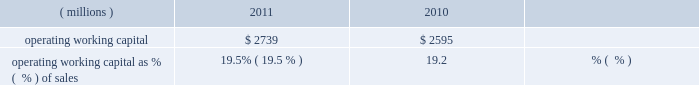Liquidity and capital resources during the past three years , we had sufficient financial resources to meet our operating requirements , to fund our capital spending , share repurchases and pension plans and to pay increasing dividends to our shareholders .
Cash from operating activities was $ 1436 million , $ 1310 million , and $ 1345 million in 2011 , 2010 , and 2009 , respectively .
Higher earnings increased cash from operations in 2011 compared to 2010 , but the increase was reduced by cash used to fund an increase in working capital of $ 212 million driven by our sales growth in 2011 .
Cash provided by working capital was greater in 2009 than 2010 and that decline was more than offset by the cash from higher 2010 earnings .
Operating working capital is a subset of total working capital and represents ( 1 ) trade receivables-net of the allowance for doubtful accounts , plus ( 2 ) inventories on a first-in , first-out ( 201cfifo 201d ) basis , less ( 3 ) trade creditors 2019 liabilities .
See note 3 , 201cworking capital detail 201d under item 8 of this form 10-k for further information related to the components of the company 2019s operating working capital .
We believe operating working capital represents the key components of working capital under the operating control of our businesses .
Operating working capital at december 31 , 2011 and 2010 was $ 2.7 billion and $ 2.6 billion , respectively .
A key metric we use to measure our working capital management is operating working capital as a percentage of sales ( fourth quarter sales annualized ) .
( millions ) 2011 2010 operating working capital $ 2739 $ 2595 operating working capital as % (  % ) of sales 19.5% ( 19.5 % ) 19.2% ( 19.2 % ) the change in operating working capital elements , excluding the impact of currency and acquisitions , was an increase of $ 195 million during the year ended december 31 , 2011 .
This increase was the net result of an increase in receivables from customers associated with the 2011 increase in sales and an increase in fifo inventory slightly offset by an increase in trade creditors 2019 liabilities .
Trade receivables from customers , net , as a percentage of fourth quarter sales , annualized , for 2011 was 17.9 percent , down slightly from 18.1 percent for 2010 .
Days sales outstanding was 66 days in 2011 , level with 2010 .
Inventories on a fifo basis as a percentage of fourth quarter sales , annualized , for 2011 was 13.1 percent level with 2010 .
Inventory turnover was 5.0 times in 2011 and 4.6 times in 2010 .
Total capital spending , including acquisitions , was $ 446 million , $ 341 million and $ 265 million in 2011 , 2010 , and 2009 , respectively .
Spending related to modernization and productivity improvements , expansion of existing businesses and environmental control projects was $ 390 million , $ 307 million and $ 239 million in 2011 , 2010 , and 2009 , respectively , and is expected to be in the range of $ 450-$ 550 million during 2012 .
Capital spending , excluding acquisitions , as a percentage of sales was 2.6% ( 2.6 % ) , 2.3% ( 2.3 % ) and 2.0% ( 2.0 % ) in 2011 , 2010 and 2009 , respectively .
Capital spending related to business acquisitions amounted to $ 56 million , $ 34 million , and $ 26 million in 2011 , 2010 and 2009 , respectively .
We continue to evaluate acquisition opportunities and expect to use cash in 2012 to fund small to mid-sized acquisitions , as part of a balanced deployment of our cash to support growth in earnings .
In january 2012 , the company closed the previously announced acquisitions of colpisa , a colombian producer of automotive oem and refinish coatings , and dyrup , a european architectural coatings company .
The cost of these acquisitions , including assumed debt , was $ 193 million .
Dividends paid to shareholders totaled $ 355 million , $ 360 million and $ 353 million in 2011 , 2010 and 2009 , respectively .
Ppg has paid uninterrupted annual dividends since 1899 , and 2011 marked the 40th consecutive year of increased annual dividend payments to shareholders .
We did not have a mandatory contribution to our u.s .
Defined benefit pension plans in 2011 ; however , we made voluntary contributions to these plans in 2011 totaling $ 50 million .
In 2010 and 2009 , we made voluntary contributions to our u.s .
Defined benefit pension plans of $ 250 and $ 360 million ( of which $ 100 million was made in ppg stock ) , respectively .
We expect to make voluntary contributions to our u.s .
Defined benefit pension plans in 2012 of up to $ 60 million .
Contributions were made to our non-u.s .
Defined benefit pension plans of $ 71 million , $ 87 million and $ 90 million ( of which approximately $ 20 million was made in ppg stock ) for 2011 , 2010 and 2009 , respectively , some of which were required by local funding requirements .
We expect to make mandatory contributions to our non-u.s .
Plans in 2012 of approximately $ 90 million .
The company 2019s share repurchase activity in 2011 , 2010 and 2009 was 10.2 million shares at a cost of $ 858 million , 8.1 million shares at a cost of $ 586 million and 1.5 million shares at a cost of $ 59 million , respectively .
We expect to make share repurchases in 2012 as part of our cash deployment focused on earnings growth .
The amount of spending will depend on the level of acquisition spending and other uses of cash , but we currently expect to spend in the range of $ 250 million to $ 500 million on share repurchases in 2012 .
We can repurchase about 9 million shares under the current authorization from the board of directors .
26 2011 ppg annual report and form 10-k .
Liquidity and capital resources during the past three years , we had sufficient financial resources to meet our operating requirements , to fund our capital spending , share repurchases and pension plans and to pay increasing dividends to our shareholders .
Cash from operating activities was $ 1436 million , $ 1310 million , and $ 1345 million in 2011 , 2010 , and 2009 , respectively .
Higher earnings increased cash from operations in 2011 compared to 2010 , but the increase was reduced by cash used to fund an increase in working capital of $ 212 million driven by our sales growth in 2011 .
Cash provided by working capital was greater in 2009 than 2010 and that decline was more than offset by the cash from higher 2010 earnings .
Operating working capital is a subset of total working capital and represents ( 1 ) trade receivables-net of the allowance for doubtful accounts , plus ( 2 ) inventories on a first-in , first-out ( 201cfifo 201d ) basis , less ( 3 ) trade creditors 2019 liabilities .
See note 3 , 201cworking capital detail 201d under item 8 of this form 10-k for further information related to the components of the company 2019s operating working capital .
We believe operating working capital represents the key components of working capital under the operating control of our businesses .
Operating working capital at december 31 , 2011 and 2010 was $ 2.7 billion and $ 2.6 billion , respectively .
A key metric we use to measure our working capital management is operating working capital as a percentage of sales ( fourth quarter sales annualized ) .
( millions ) 2011 2010 operating working capital $ 2739 $ 2595 operating working capital as % (  % ) of sales 19.5% ( 19.5 % ) 19.2% ( 19.2 % ) the change in operating working capital elements , excluding the impact of currency and acquisitions , was an increase of $ 195 million during the year ended december 31 , 2011 .
This increase was the net result of an increase in receivables from customers associated with the 2011 increase in sales and an increase in fifo inventory slightly offset by an increase in trade creditors 2019 liabilities .
Trade receivables from customers , net , as a percentage of fourth quarter sales , annualized , for 2011 was 17.9 percent , down slightly from 18.1 percent for 2010 .
Days sales outstanding was 66 days in 2011 , level with 2010 .
Inventories on a fifo basis as a percentage of fourth quarter sales , annualized , for 2011 was 13.1 percent level with 2010 .
Inventory turnover was 5.0 times in 2011 and 4.6 times in 2010 .
Total capital spending , including acquisitions , was $ 446 million , $ 341 million and $ 265 million in 2011 , 2010 , and 2009 , respectively .
Spending related to modernization and productivity improvements , expansion of existing businesses and environmental control projects was $ 390 million , $ 307 million and $ 239 million in 2011 , 2010 , and 2009 , respectively , and is expected to be in the range of $ 450-$ 550 million during 2012 .
Capital spending , excluding acquisitions , as a percentage of sales was 2.6% ( 2.6 % ) , 2.3% ( 2.3 % ) and 2.0% ( 2.0 % ) in 2011 , 2010 and 2009 , respectively .
Capital spending related to business acquisitions amounted to $ 56 million , $ 34 million , and $ 26 million in 2011 , 2010 and 2009 , respectively .
We continue to evaluate acquisition opportunities and expect to use cash in 2012 to fund small to mid-sized acquisitions , as part of a balanced deployment of our cash to support growth in earnings .
In january 2012 , the company closed the previously announced acquisitions of colpisa , a colombian producer of automotive oem and refinish coatings , and dyrup , a european architectural coatings company .
The cost of these acquisitions , including assumed debt , was $ 193 million .
Dividends paid to shareholders totaled $ 355 million , $ 360 million and $ 353 million in 2011 , 2010 and 2009 , respectively .
Ppg has paid uninterrupted annual dividends since 1899 , and 2011 marked the 40th consecutive year of increased annual dividend payments to shareholders .
We did not have a mandatory contribution to our u.s .
Defined benefit pension plans in 2011 ; however , we made voluntary contributions to these plans in 2011 totaling $ 50 million .
In 2010 and 2009 , we made voluntary contributions to our u.s .
Defined benefit pension plans of $ 250 and $ 360 million ( of which $ 100 million was made in ppg stock ) , respectively .
We expect to make voluntary contributions to our u.s .
Defined benefit pension plans in 2012 of up to $ 60 million .
Contributions were made to our non-u.s .
Defined benefit pension plans of $ 71 million , $ 87 million and $ 90 million ( of which approximately $ 20 million was made in ppg stock ) for 2011 , 2010 and 2009 , respectively , some of which were required by local funding requirements .
We expect to make mandatory contributions to our non-u.s .
Plans in 2012 of approximately $ 90 million .
The company 2019s share repurchase activity in 2011 , 2010 and 2009 was 10.2 million shares at a cost of $ 858 million , 8.1 million shares at a cost of $ 586 million and 1.5 million shares at a cost of $ 59 million , respectively .
We expect to make share repurchases in 2012 as part of our cash deployment focused on earnings growth .
The amount of spending will depend on the level of acquisition spending and other uses of cash , but we currently expect to spend in the range of $ 250 million to $ 500 million on share repurchases in 2012 .
We can repurchase about 9 million shares under the current authorization from the board of directors .
26 2011 ppg annual report and form 10-k .
If trade receivables from customers trends at the same rate as 2011 , what will the 2012 allowance be as a percentage of fourth quarter sales? 
Computations: (17.9 - (17.9 - 18.1))
Answer: 18.1. Liquidity and capital resources during the past three years , we had sufficient financial resources to meet our operating requirements , to fund our capital spending , share repurchases and pension plans and to pay increasing dividends to our shareholders .
Cash from operating activities was $ 1436 million , $ 1310 million , and $ 1345 million in 2011 , 2010 , and 2009 , respectively .
Higher earnings increased cash from operations in 2011 compared to 2010 , but the increase was reduced by cash used to fund an increase in working capital of $ 212 million driven by our sales growth in 2011 .
Cash provided by working capital was greater in 2009 than 2010 and that decline was more than offset by the cash from higher 2010 earnings .
Operating working capital is a subset of total working capital and represents ( 1 ) trade receivables-net of the allowance for doubtful accounts , plus ( 2 ) inventories on a first-in , first-out ( 201cfifo 201d ) basis , less ( 3 ) trade creditors 2019 liabilities .
See note 3 , 201cworking capital detail 201d under item 8 of this form 10-k for further information related to the components of the company 2019s operating working capital .
We believe operating working capital represents the key components of working capital under the operating control of our businesses .
Operating working capital at december 31 , 2011 and 2010 was $ 2.7 billion and $ 2.6 billion , respectively .
A key metric we use to measure our working capital management is operating working capital as a percentage of sales ( fourth quarter sales annualized ) .
( millions ) 2011 2010 operating working capital $ 2739 $ 2595 operating working capital as % (  % ) of sales 19.5% ( 19.5 % ) 19.2% ( 19.2 % ) the change in operating working capital elements , excluding the impact of currency and acquisitions , was an increase of $ 195 million during the year ended december 31 , 2011 .
This increase was the net result of an increase in receivables from customers associated with the 2011 increase in sales and an increase in fifo inventory slightly offset by an increase in trade creditors 2019 liabilities .
Trade receivables from customers , net , as a percentage of fourth quarter sales , annualized , for 2011 was 17.9 percent , down slightly from 18.1 percent for 2010 .
Days sales outstanding was 66 days in 2011 , level with 2010 .
Inventories on a fifo basis as a percentage of fourth quarter sales , annualized , for 2011 was 13.1 percent level with 2010 .
Inventory turnover was 5.0 times in 2011 and 4.6 times in 2010 .
Total capital spending , including acquisitions , was $ 446 million , $ 341 million and $ 265 million in 2011 , 2010 , and 2009 , respectively .
Spending related to modernization and productivity improvements , expansion of existing businesses and environmental control projects was $ 390 million , $ 307 million and $ 239 million in 2011 , 2010 , and 2009 , respectively , and is expected to be in the range of $ 450-$ 550 million during 2012 .
Capital spending , excluding acquisitions , as a percentage of sales was 2.6% ( 2.6 % ) , 2.3% ( 2.3 % ) and 2.0% ( 2.0 % ) in 2011 , 2010 and 2009 , respectively .
Capital spending related to business acquisitions amounted to $ 56 million , $ 34 million , and $ 26 million in 2011 , 2010 and 2009 , respectively .
We continue to evaluate acquisition opportunities and expect to use cash in 2012 to fund small to mid-sized acquisitions , as part of a balanced deployment of our cash to support growth in earnings .
In january 2012 , the company closed the previously announced acquisitions of colpisa , a colombian producer of automotive oem and refinish coatings , and dyrup , a european architectural coatings company .
The cost of these acquisitions , including assumed debt , was $ 193 million .
Dividends paid to shareholders totaled $ 355 million , $ 360 million and $ 353 million in 2011 , 2010 and 2009 , respectively .
Ppg has paid uninterrupted annual dividends since 1899 , and 2011 marked the 40th consecutive year of increased annual dividend payments to shareholders .
We did not have a mandatory contribution to our u.s .
Defined benefit pension plans in 2011 ; however , we made voluntary contributions to these plans in 2011 totaling $ 50 million .
In 2010 and 2009 , we made voluntary contributions to our u.s .
Defined benefit pension plans of $ 250 and $ 360 million ( of which $ 100 million was made in ppg stock ) , respectively .
We expect to make voluntary contributions to our u.s .
Defined benefit pension plans in 2012 of up to $ 60 million .
Contributions were made to our non-u.s .
Defined benefit pension plans of $ 71 million , $ 87 million and $ 90 million ( of which approximately $ 20 million was made in ppg stock ) for 2011 , 2010 and 2009 , respectively , some of which were required by local funding requirements .
We expect to make mandatory contributions to our non-u.s .
Plans in 2012 of approximately $ 90 million .
The company 2019s share repurchase activity in 2011 , 2010 and 2009 was 10.2 million shares at a cost of $ 858 million , 8.1 million shares at a cost of $ 586 million and 1.5 million shares at a cost of $ 59 million , respectively .
We expect to make share repurchases in 2012 as part of our cash deployment focused on earnings growth .
The amount of spending will depend on the level of acquisition spending and other uses of cash , but we currently expect to spend in the range of $ 250 million to $ 500 million on share repurchases in 2012 .
We can repurchase about 9 million shares under the current authorization from the board of directors .
26 2011 ppg annual report and form 10-k .
Liquidity and capital resources during the past three years , we had sufficient financial resources to meet our operating requirements , to fund our capital spending , share repurchases and pension plans and to pay increasing dividends to our shareholders .
Cash from operating activities was $ 1436 million , $ 1310 million , and $ 1345 million in 2011 , 2010 , and 2009 , respectively .
Higher earnings increased cash from operations in 2011 compared to 2010 , but the increase was reduced by cash used to fund an increase in working capital of $ 212 million driven by our sales growth in 2011 .
Cash provided by working capital was greater in 2009 than 2010 and that decline was more than offset by the cash from higher 2010 earnings .
Operating working capital is a subset of total working capital and represents ( 1 ) trade receivables-net of the allowance for doubtful accounts , plus ( 2 ) inventories on a first-in , first-out ( 201cfifo 201d ) basis , less ( 3 ) trade creditors 2019 liabilities .
See note 3 , 201cworking capital detail 201d under item 8 of this form 10-k for further information related to the components of the company 2019s operating working capital .
We believe operating working capital represents the key components of working capital under the operating control of our businesses .
Operating working capital at december 31 , 2011 and 2010 was $ 2.7 billion and $ 2.6 billion , respectively .
A key metric we use to measure our working capital management is operating working capital as a percentage of sales ( fourth quarter sales annualized ) .
( millions ) 2011 2010 operating working capital $ 2739 $ 2595 operating working capital as % (  % ) of sales 19.5% ( 19.5 % ) 19.2% ( 19.2 % ) the change in operating working capital elements , excluding the impact of currency and acquisitions , was an increase of $ 195 million during the year ended december 31 , 2011 .
This increase was the net result of an increase in receivables from customers associated with the 2011 increase in sales and an increase in fifo inventory slightly offset by an increase in trade creditors 2019 liabilities .
Trade receivables from customers , net , as a percentage of fourth quarter sales , annualized , for 2011 was 17.9 percent , down slightly from 18.1 percent for 2010 .
Days sales outstanding was 66 days in 2011 , level with 2010 .
Inventories on a fifo basis as a percentage of fourth quarter sales , annualized , for 2011 was 13.1 percent level with 2010 .
Inventory turnover was 5.0 times in 2011 and 4.6 times in 2010 .
Total capital spending , including acquisitions , was $ 446 million , $ 341 million and $ 265 million in 2011 , 2010 , and 2009 , respectively .
Spending related to modernization and productivity improvements , expansion of existing businesses and environmental control projects was $ 390 million , $ 307 million and $ 239 million in 2011 , 2010 , and 2009 , respectively , and is expected to be in the range of $ 450-$ 550 million during 2012 .
Capital spending , excluding acquisitions , as a percentage of sales was 2.6% ( 2.6 % ) , 2.3% ( 2.3 % ) and 2.0% ( 2.0 % ) in 2011 , 2010 and 2009 , respectively .
Capital spending related to business acquisitions amounted to $ 56 million , $ 34 million , and $ 26 million in 2011 , 2010 and 2009 , respectively .
We continue to evaluate acquisition opportunities and expect to use cash in 2012 to fund small to mid-sized acquisitions , as part of a balanced deployment of our cash to support growth in earnings .
In january 2012 , the company closed the previously announced acquisitions of colpisa , a colombian producer of automotive oem and refinish coatings , and dyrup , a european architectural coatings company .
The cost of these acquisitions , including assumed debt , was $ 193 million .
Dividends paid to shareholders totaled $ 355 million , $ 360 million and $ 353 million in 2011 , 2010 and 2009 , respectively .
Ppg has paid uninterrupted annual dividends since 1899 , and 2011 marked the 40th consecutive year of increased annual dividend payments to shareholders .
We did not have a mandatory contribution to our u.s .
Defined benefit pension plans in 2011 ; however , we made voluntary contributions to these plans in 2011 totaling $ 50 million .
In 2010 and 2009 , we made voluntary contributions to our u.s .
Defined benefit pension plans of $ 250 and $ 360 million ( of which $ 100 million was made in ppg stock ) , respectively .
We expect to make voluntary contributions to our u.s .
Defined benefit pension plans in 2012 of up to $ 60 million .
Contributions were made to our non-u.s .
Defined benefit pension plans of $ 71 million , $ 87 million and $ 90 million ( of which approximately $ 20 million was made in ppg stock ) for 2011 , 2010 and 2009 , respectively , some of which were required by local funding requirements .
We expect to make mandatory contributions to our non-u.s .
Plans in 2012 of approximately $ 90 million .
The company 2019s share repurchase activity in 2011 , 2010 and 2009 was 10.2 million shares at a cost of $ 858 million , 8.1 million shares at a cost of $ 586 million and 1.5 million shares at a cost of $ 59 million , respectively .
We expect to make share repurchases in 2012 as part of our cash deployment focused on earnings growth .
The amount of spending will depend on the level of acquisition spending and other uses of cash , but we currently expect to spend in the range of $ 250 million to $ 500 million on share repurchases in 2012 .
We can repurchase about 9 million shares under the current authorization from the board of directors .
26 2011 ppg annual report and form 10-k .
What was the percentage change in cash from operating activities from 2009 to 2010? 
Computations: ((1310 - 1345) / 1345)
Answer: -0.02602. 